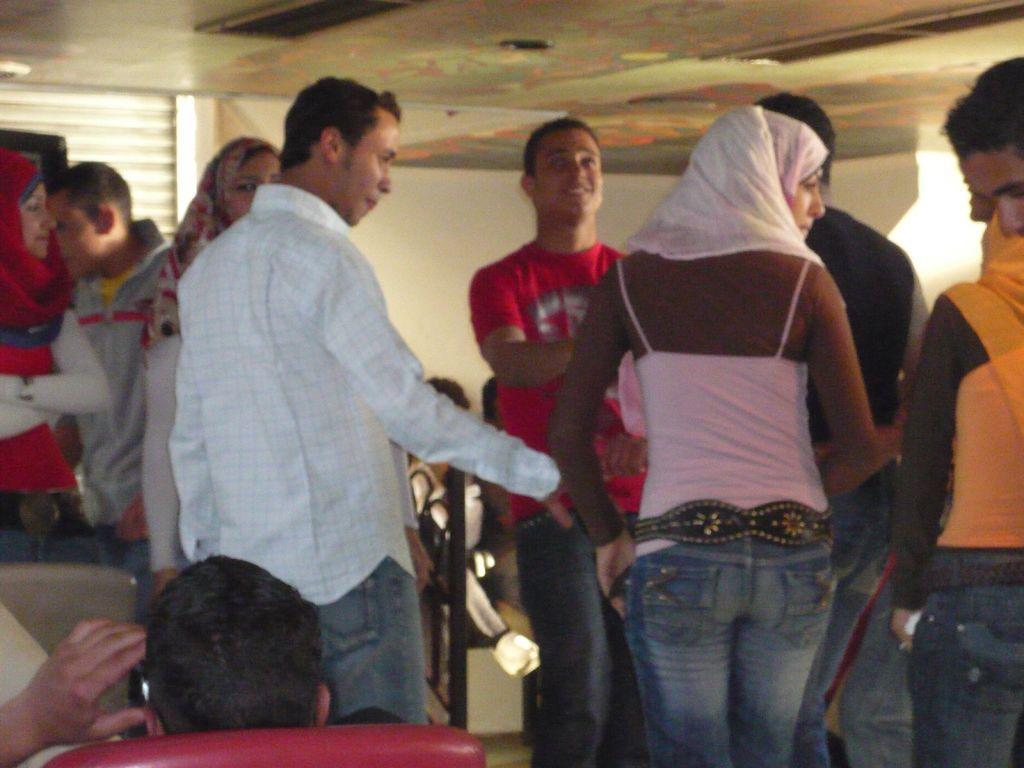Can you describe this image briefly? In the picture I can see a person is sitting on the red color chair and is on the left side of the image and we can see a few more people standing on the floor. In the background, I can see the wall and ceiling. 